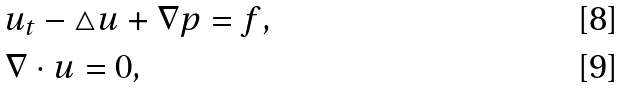Convert formula to latex. <formula><loc_0><loc_0><loc_500><loc_500>& u _ { t } - \triangle u + \nabla p = f , \\ & \nabla \cdot u = 0 ,</formula> 